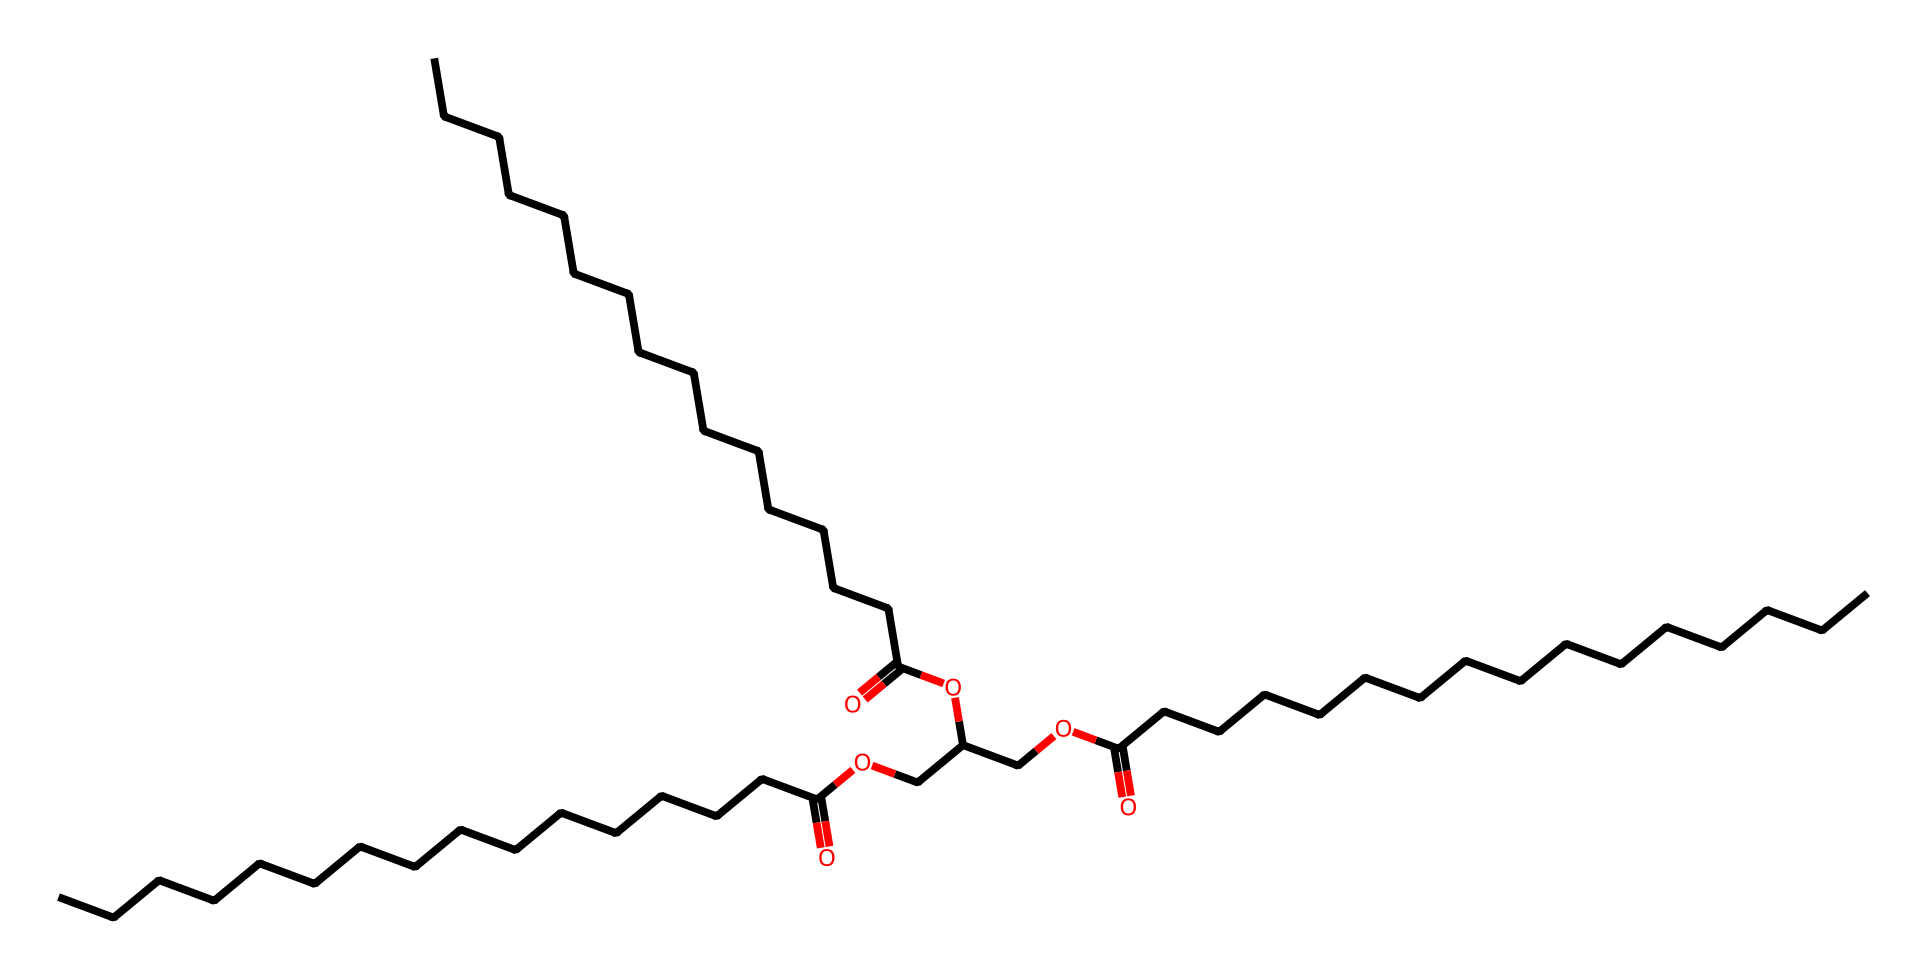What is the main functional group present in the chemical? The presence of the carboxyl groups (−COOH), indicated by the carbonyl (C=O) and hydroxyl (−OH) functionalities in the structure, identifies it as a carboxylic acid.
Answer: carboxylic acid How many carbon atoms are present in this chemical? By counting the number of carbon (C) symbols in the SMILES representation and considering the structure, there are 36 carbon atoms total.
Answer: 36 What type of lipids does this chemical represent? The structure indicates that it contains fatty acid esters and possibly waxes due to the ester groups linking fatty acid chains, common in lipids.
Answer: wax How many ester linkages can be found in the molecule? The structure has three ester linkages, as indicated by the presence of multiple ether-like connections (RCOOR) between carbon chains throughout the chemical representation.
Answer: 3 Is this compound likely to be saturated or unsaturated? The structure shows that all carbon chains appear to be fully saturated, as there are no double bonds noted in the SMILES representation.
Answer: saturated What role does lanolin typically play in pet grooming products? Lanolin serves as a moisturizer and emollient due to its lipid nature, which helps in hydrating the skin and protecting the fur.
Answer: moisturizer 